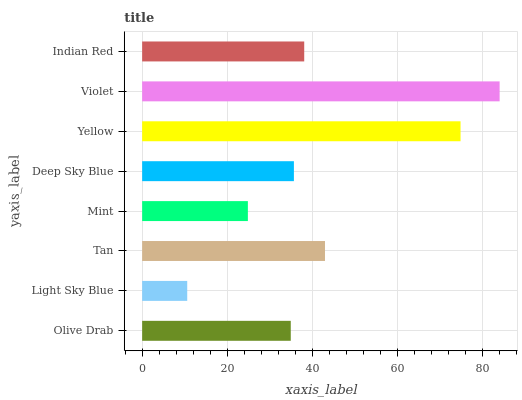Is Light Sky Blue the minimum?
Answer yes or no. Yes. Is Violet the maximum?
Answer yes or no. Yes. Is Tan the minimum?
Answer yes or no. No. Is Tan the maximum?
Answer yes or no. No. Is Tan greater than Light Sky Blue?
Answer yes or no. Yes. Is Light Sky Blue less than Tan?
Answer yes or no. Yes. Is Light Sky Blue greater than Tan?
Answer yes or no. No. Is Tan less than Light Sky Blue?
Answer yes or no. No. Is Indian Red the high median?
Answer yes or no. Yes. Is Deep Sky Blue the low median?
Answer yes or no. Yes. Is Violet the high median?
Answer yes or no. No. Is Violet the low median?
Answer yes or no. No. 